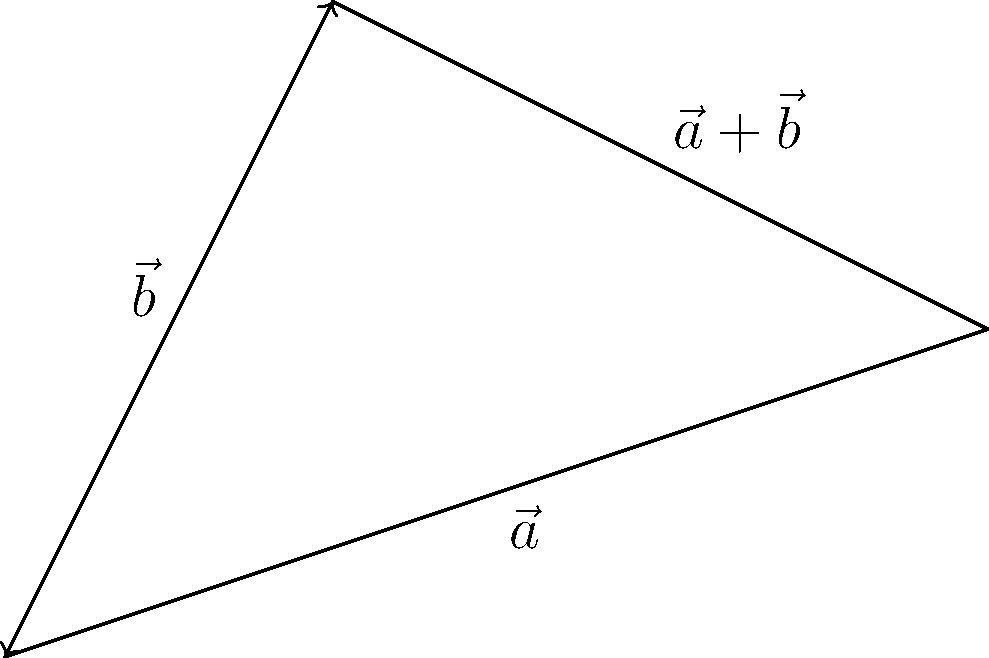In the diagram, vectors $\vec{a}$ and $\vec{b}$ are represented by arrows. Using the parallelogram method, what is the magnitude of the resultant vector $\vec{a}+\vec{b}$? (Assume each grid unit represents 1 unit of magnitude) To find the magnitude of the resultant vector $\vec{a}+\vec{b}$ using the parallelogram method, we'll follow these steps:

1. Identify the components of vectors $\vec{a}$ and $\vec{b}$:
   $\vec{a} = (3,1)$
   $\vec{b} = (1,2)$

2. Add the components to find the resultant vector:
   $\vec{a}+\vec{b} = (3+1, 1+2) = (4,3)$

3. Calculate the magnitude of the resultant vector using the Pythagorean theorem:
   $|\vec{a}+\vec{b}| = \sqrt{(4)^2 + (3)^2}$

4. Simplify:
   $|\vec{a}+\vec{b}| = \sqrt{16 + 9} = \sqrt{25} = 5$

Therefore, the magnitude of the resultant vector $\vec{a}+\vec{b}$ is 5 units.
Answer: 5 units 